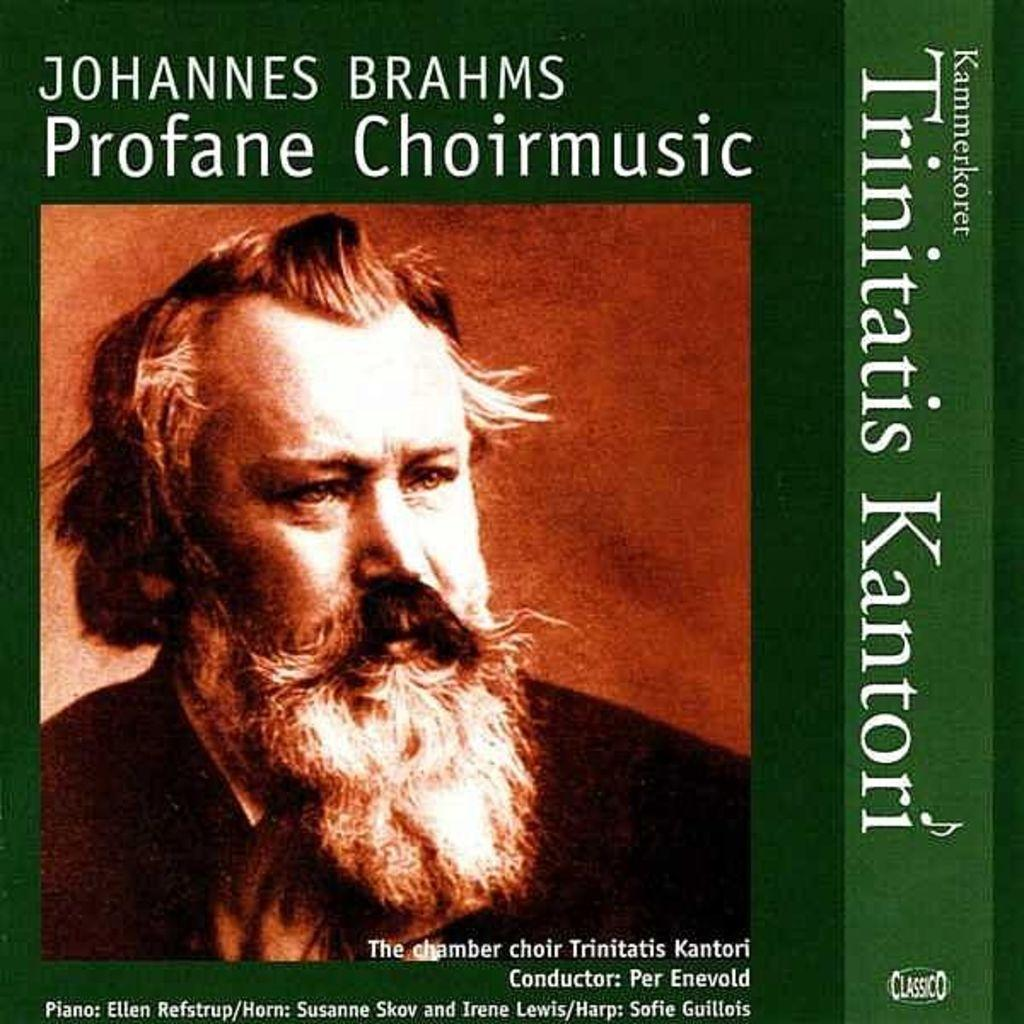What is the main subject in the center of the image? There is a poster in the center of the image. What can be seen on the poster? There is a person depicted on the poster, along with text. What type of design can be seen on the balls in the image? There are no balls present in the image; it only features a poster with a person and text. 